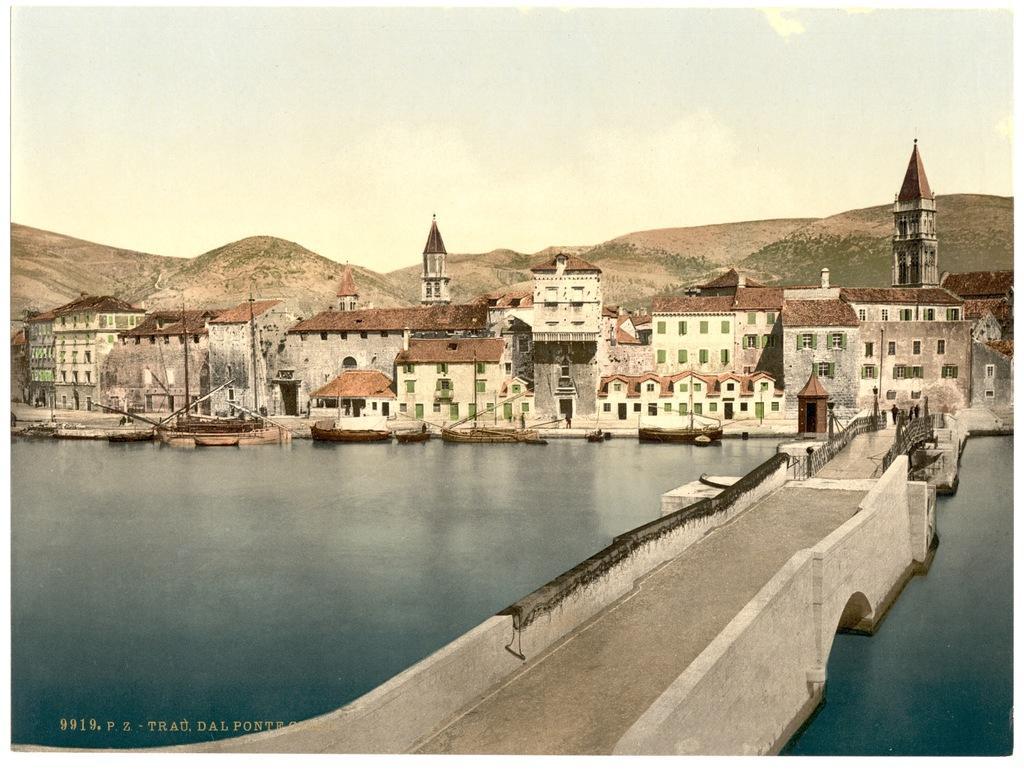How would you summarize this image in a sentence or two? In this picture we can see a bridge in the front, on the left side there is water, we can see some boats on the water, in the background there are some buildings, we can see the sky at the top of the picture, at the left bottom there is some text. 